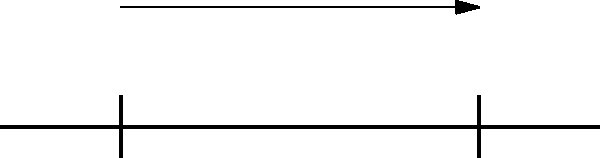In a tribute to the Osmonds' musical structure, imagine a beam supporting a distributed load, much like how the band supported each other's harmonies. Given a simply supported beam of length 6 m with a uniformly distributed load of 5 kN/m across its entire span, determine the maximum shear force and bending moment in the beam. How might these values relate to the peaks and valleys in the Osmonds' career? Let's approach this step-by-step, much like arranging a classic Osmonds hit:

1) First, calculate the total load on the beam:
   Total load = $w \times L = 5 \text{ kN/m} \times 6 \text{ m} = 30 \text{ kN}$

2) For a simply supported beam with a uniformly distributed load, the reactions at the supports are equal and each carry half the total load:
   $R_A = R_B = \frac{30 \text{ kN}}{2} = 15 \text{ kN}$

3) The maximum shear force occurs at the supports and is equal to the reaction force:
   $V_{max} = 15 \text{ kN}$

4) The maximum bending moment occurs at the center of the beam and is given by the formula:
   $M_{max} = \frac{wL^2}{8} = \frac{5 \text{ kN/m} \times (6 \text{ m})^2}{8} = 22.5 \text{ kN}\cdot\text{m}$

Just as the Osmonds' career had its high points (like the maximum bending moment) and sharp transitions (like the maximum shear force), this beam analysis shows similar characteristics. The maximum shear force at the supports represents the abrupt changes in the band's style or lineup, while the maximum bending moment at the center could symbolize the peak of their popularity and musical influence.
Answer: $V_{max} = 15 \text{ kN}$, $M_{max} = 22.5 \text{ kN}\cdot\text{m}$ 